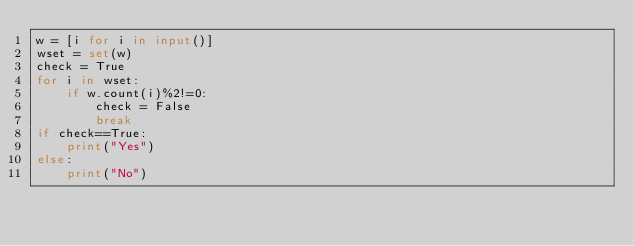<code> <loc_0><loc_0><loc_500><loc_500><_Python_>w = [i for i in input()]
wset = set(w)
check = True
for i in wset:
    if w.count(i)%2!=0:
        check = False
        break
if check==True:
    print("Yes")
else:
    print("No")</code> 